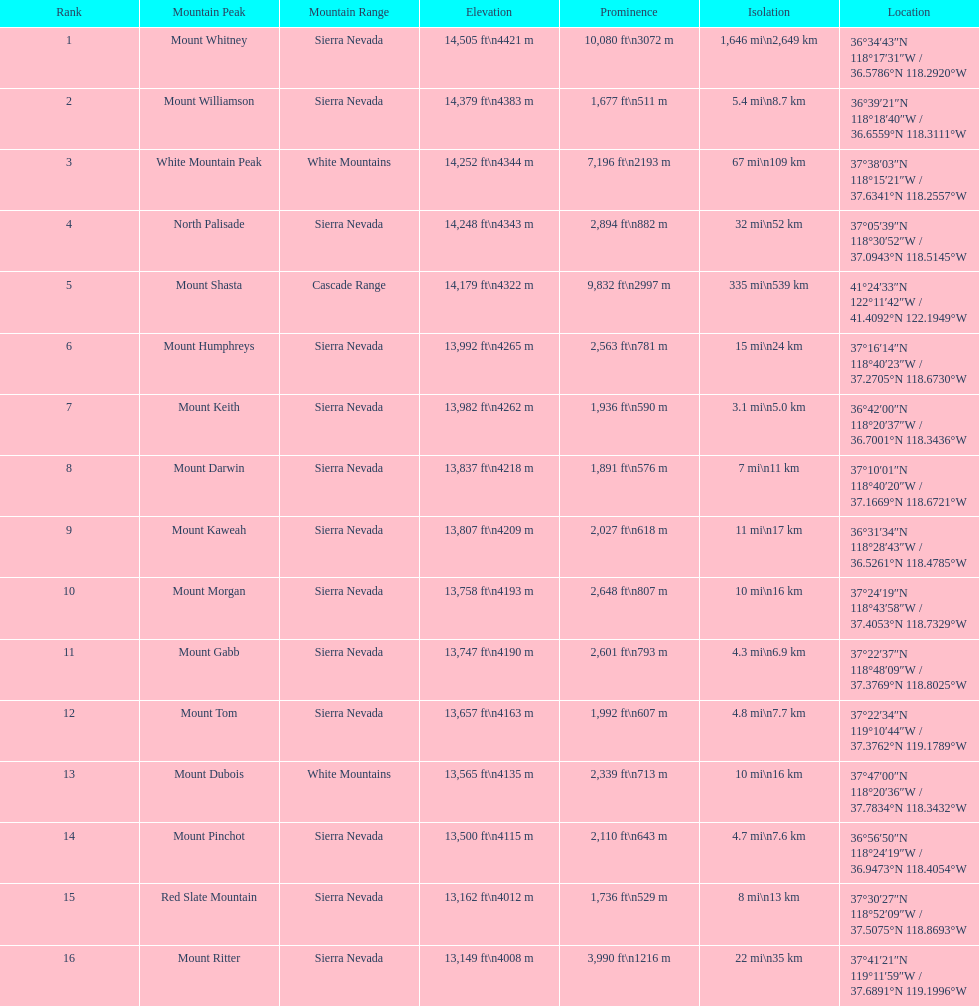What is the next loftiest mountain peak after north palisade? Mount Shasta. 